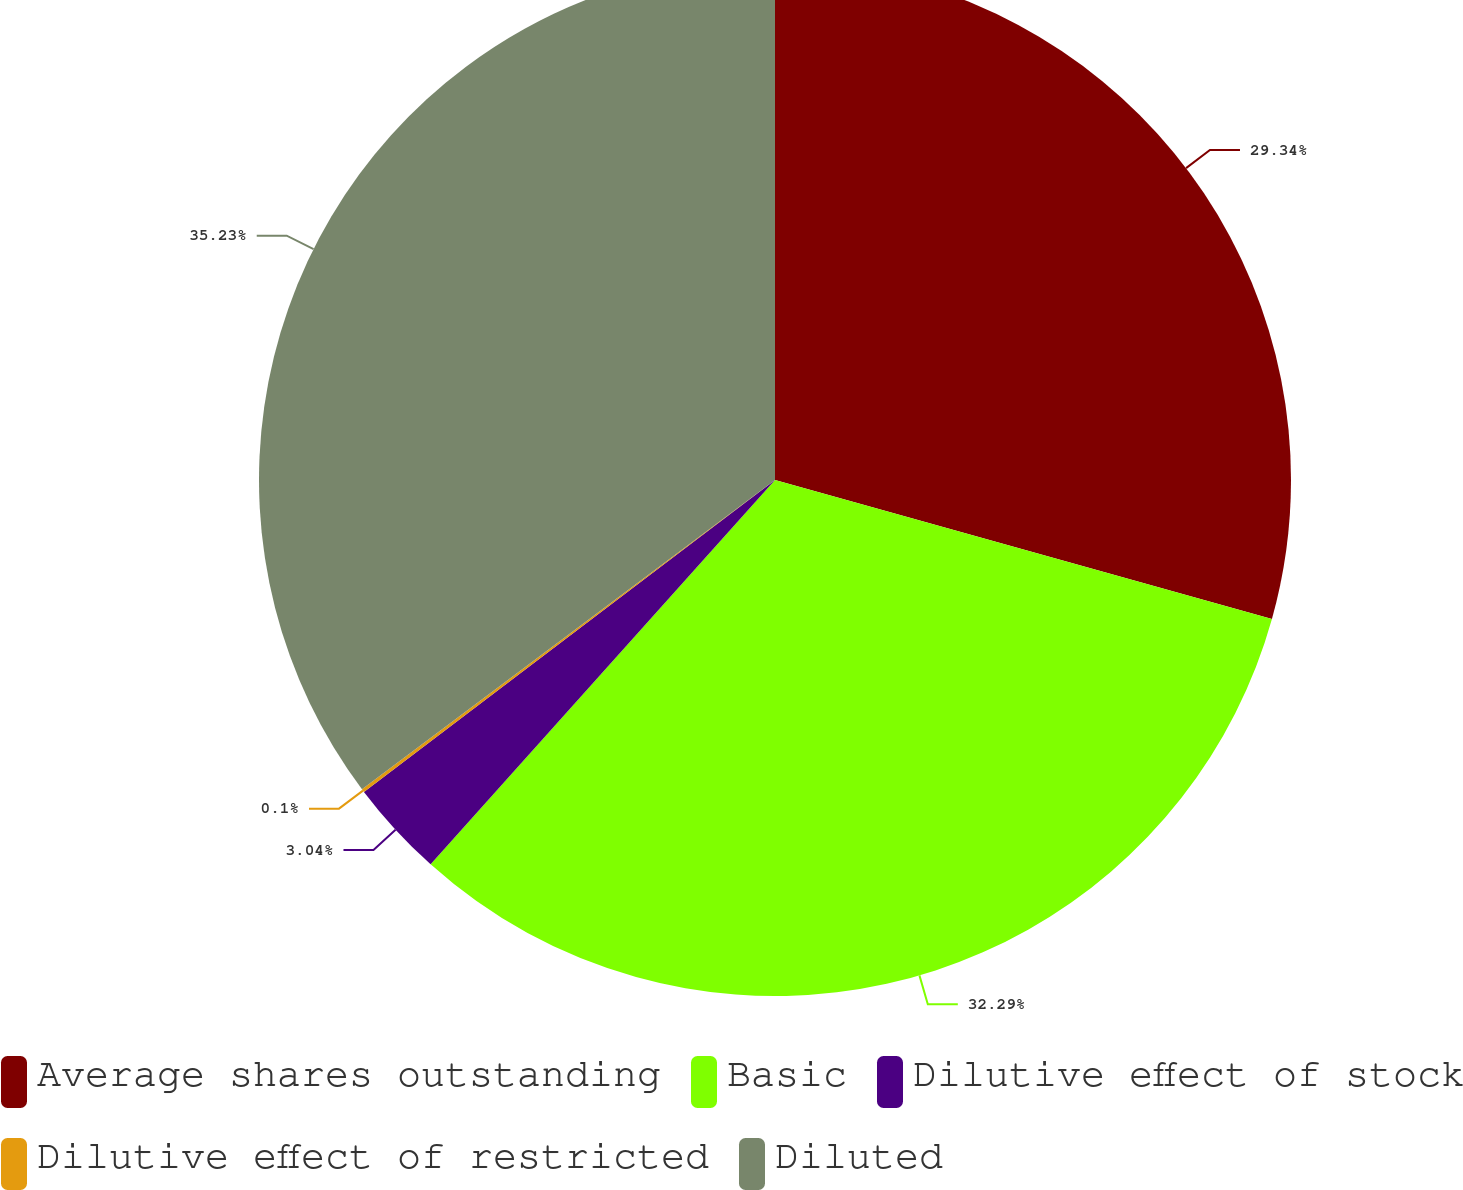Convert chart to OTSL. <chart><loc_0><loc_0><loc_500><loc_500><pie_chart><fcel>Average shares outstanding<fcel>Basic<fcel>Dilutive effect of stock<fcel>Dilutive effect of restricted<fcel>Diluted<nl><fcel>29.34%<fcel>32.29%<fcel>3.04%<fcel>0.1%<fcel>35.23%<nl></chart> 